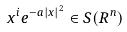<formula> <loc_0><loc_0><loc_500><loc_500>x ^ { i } e ^ { - a | x | ^ { 2 } } \in S ( R ^ { n } )</formula> 